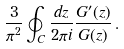<formula> <loc_0><loc_0><loc_500><loc_500>\frac { 3 } { \pi ^ { 2 } } \oint _ { C } \frac { d z } { 2 \pi i } \frac { G ^ { \prime } ( z ) } { G ( z ) } \, .</formula> 